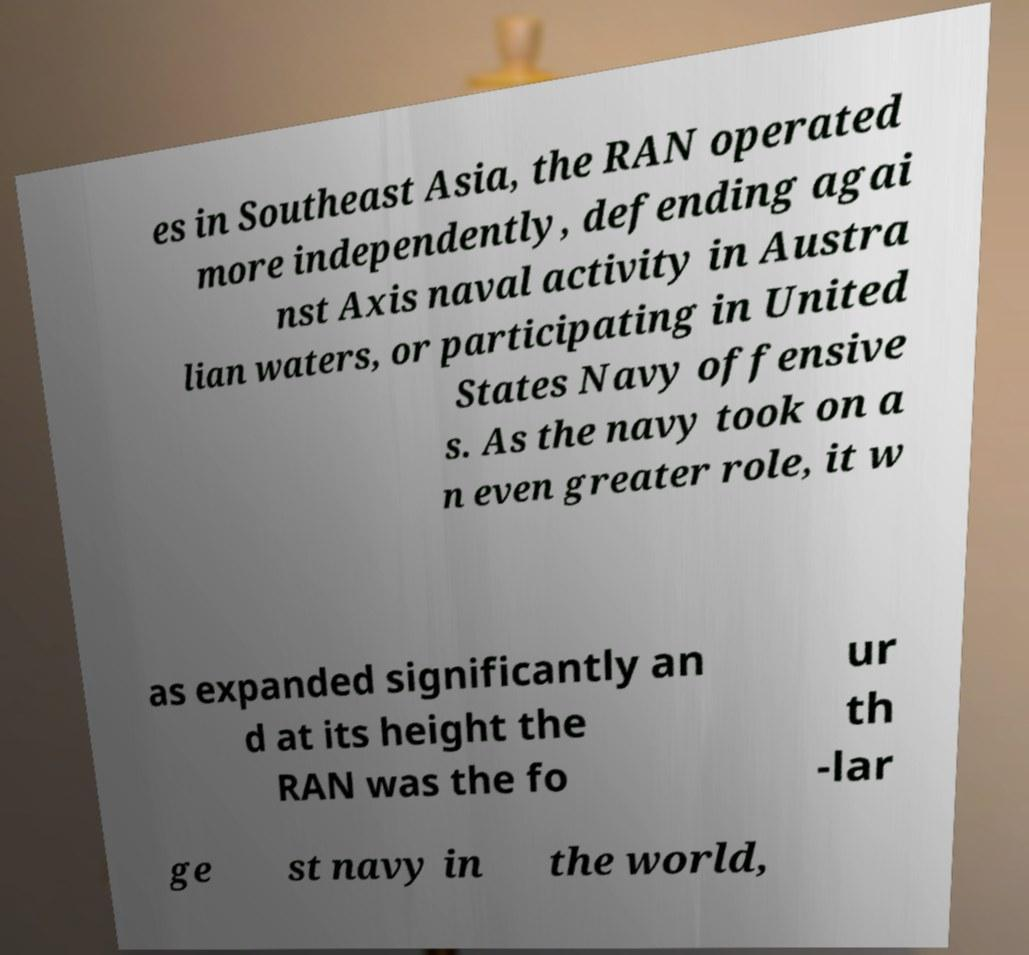Could you assist in decoding the text presented in this image and type it out clearly? es in Southeast Asia, the RAN operated more independently, defending agai nst Axis naval activity in Austra lian waters, or participating in United States Navy offensive s. As the navy took on a n even greater role, it w as expanded significantly an d at its height the RAN was the fo ur th -lar ge st navy in the world, 